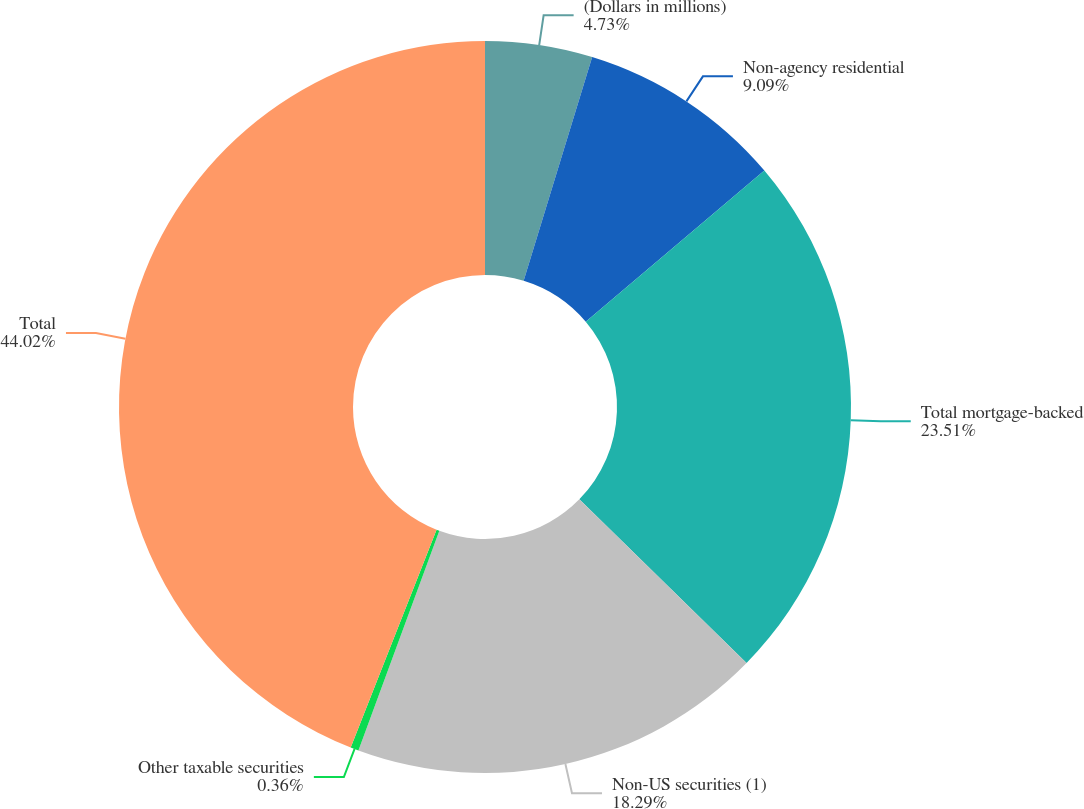<chart> <loc_0><loc_0><loc_500><loc_500><pie_chart><fcel>(Dollars in millions)<fcel>Non-agency residential<fcel>Total mortgage-backed<fcel>Non-US securities (1)<fcel>Other taxable securities<fcel>Total<nl><fcel>4.73%<fcel>9.09%<fcel>23.51%<fcel>18.29%<fcel>0.36%<fcel>44.02%<nl></chart> 